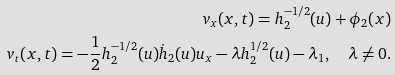<formula> <loc_0><loc_0><loc_500><loc_500>v _ { x } ( x , t ) = h _ { 2 } ^ { - 1 / 2 } ( u ) + \phi _ { 2 } ( x ) \\ v _ { t } ( x , t ) = - \frac { 1 } { 2 } h _ { 2 } ^ { - 1 / 2 } ( u ) \dot { h } _ { 2 } ( u ) u _ { x } - \lambda h _ { 2 } ^ { 1 / 2 } ( u ) - \lambda _ { 1 } , \quad \lambda \neq 0 .</formula> 